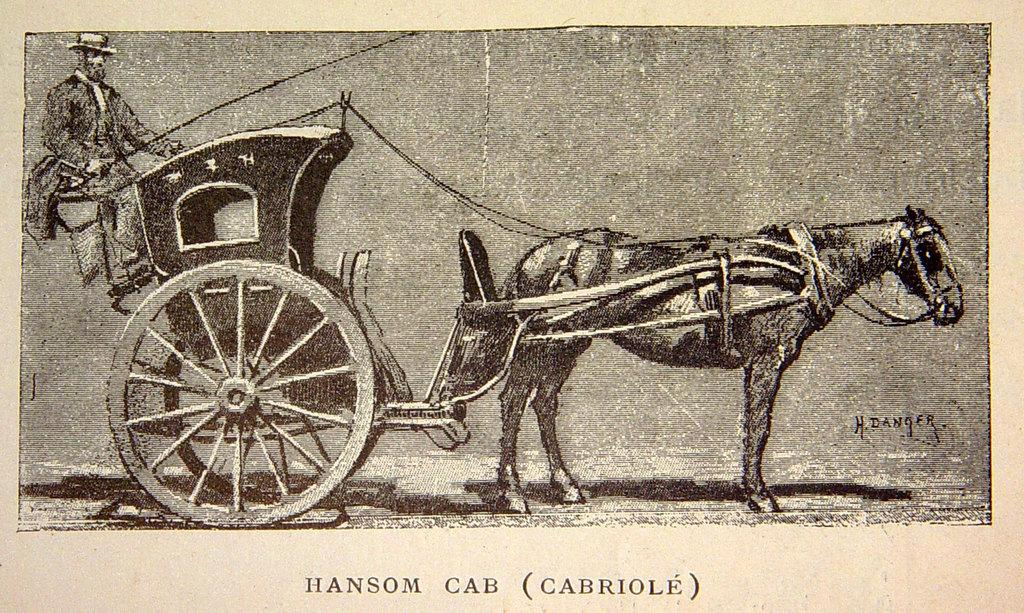What is the main subject of the image? There is a photograph in the image. What can be seen in the photograph? There is a horse cart on the ground and a person in the photograph. Is there any text visible in the photograph? Yes, there is some text visible in the photograph. What type of police show is being filmed in the image? There is no indication of a police show or any filming in the image. The image contains a photograph with a horse cart, a person, and some text. 